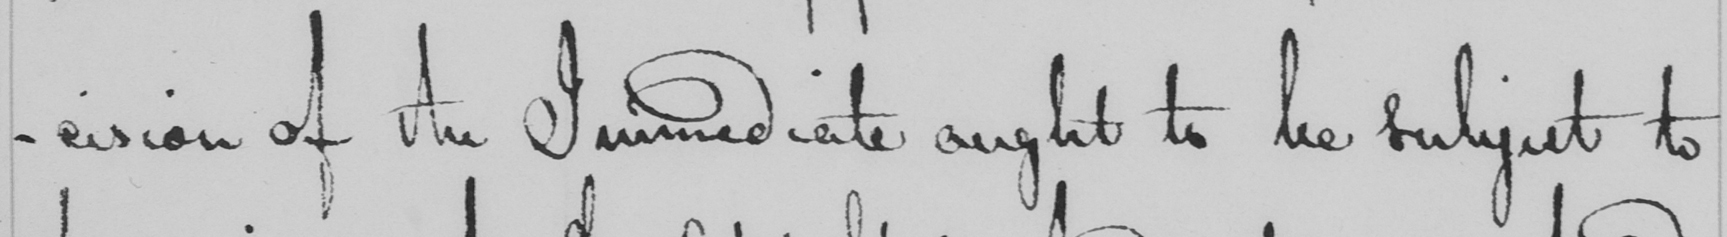Can you read and transcribe this handwriting? -cision of the Immediate ought to be subject to 